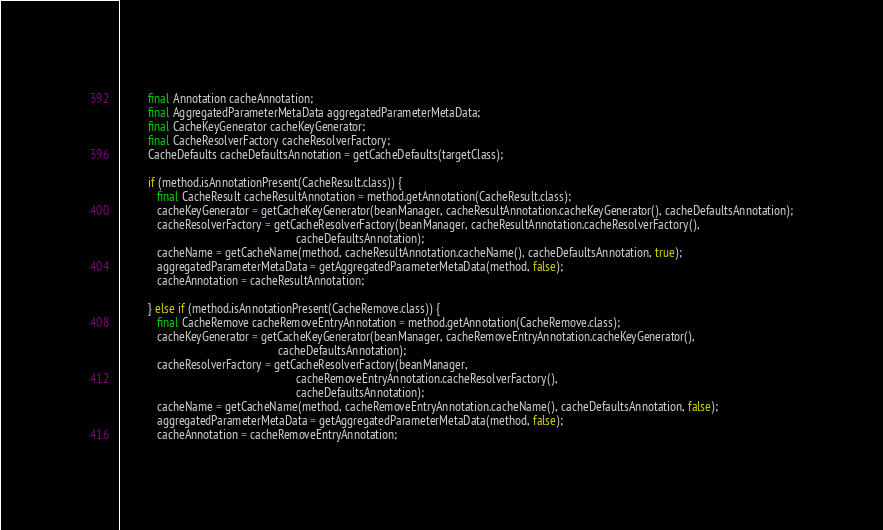Convert code to text. <code><loc_0><loc_0><loc_500><loc_500><_Java_>         final Annotation cacheAnnotation;
         final AggregatedParameterMetaData aggregatedParameterMetaData;
         final CacheKeyGenerator cacheKeyGenerator;
         final CacheResolverFactory cacheResolverFactory;
         CacheDefaults cacheDefaultsAnnotation = getCacheDefaults(targetClass);

         if (method.isAnnotationPresent(CacheResult.class)) {
            final CacheResult cacheResultAnnotation = method.getAnnotation(CacheResult.class);
            cacheKeyGenerator = getCacheKeyGenerator(beanManager, cacheResultAnnotation.cacheKeyGenerator(), cacheDefaultsAnnotation);
            cacheResolverFactory = getCacheResolverFactory(beanManager, cacheResultAnnotation.cacheResolverFactory(),
                                                           cacheDefaultsAnnotation);
            cacheName = getCacheName(method, cacheResultAnnotation.cacheName(), cacheDefaultsAnnotation, true);
            aggregatedParameterMetaData = getAggregatedParameterMetaData(method, false);
            cacheAnnotation = cacheResultAnnotation;

         } else if (method.isAnnotationPresent(CacheRemove.class)) {
            final CacheRemove cacheRemoveEntryAnnotation = method.getAnnotation(CacheRemove.class);
            cacheKeyGenerator = getCacheKeyGenerator(beanManager, cacheRemoveEntryAnnotation.cacheKeyGenerator(),
                                                     cacheDefaultsAnnotation);
            cacheResolverFactory = getCacheResolverFactory(beanManager,
                                                           cacheRemoveEntryAnnotation.cacheResolverFactory(),
                                                           cacheDefaultsAnnotation);
            cacheName = getCacheName(method, cacheRemoveEntryAnnotation.cacheName(), cacheDefaultsAnnotation, false);
            aggregatedParameterMetaData = getAggregatedParameterMetaData(method, false);
            cacheAnnotation = cacheRemoveEntryAnnotation;
</code> 